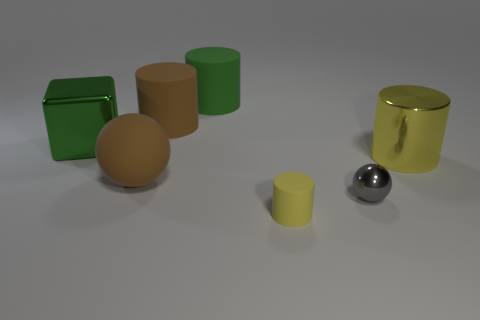How many metallic objects are either yellow cylinders or small green balls?
Your answer should be compact. 1. There is a gray metallic sphere that is in front of the big green cube; what is its size?
Provide a short and direct response. Small. Is the tiny yellow matte thing the same shape as the large green rubber thing?
Make the answer very short. Yes. What number of tiny things are green rubber blocks or green metal blocks?
Offer a very short reply. 0. Are there any gray balls right of the green cube?
Provide a succinct answer. Yes. Are there the same number of large objects to the right of the gray object and gray balls?
Provide a short and direct response. Yes. The other thing that is the same shape as the gray shiny object is what size?
Your answer should be compact. Large. Does the green matte thing have the same shape as the big brown rubber object behind the big metallic cylinder?
Ensure brevity in your answer.  Yes. There is a yellow thing that is right of the tiny gray metallic sphere that is to the right of the tiny yellow cylinder; what size is it?
Provide a succinct answer. Large. Is the number of large objects in front of the big block the same as the number of large rubber objects behind the yellow shiny thing?
Keep it short and to the point. Yes. 